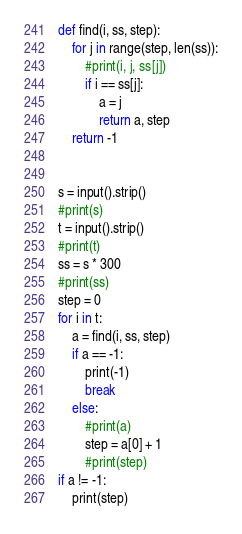Convert code to text. <code><loc_0><loc_0><loc_500><loc_500><_Python_>def find(i, ss, step):
    for j in range(step, len(ss)):
        #print(i, j, ss[j])
        if i == ss[j]:
            a = j
            return a, step
    return -1


s = input().strip()
#print(s)
t = input().strip()
#print(t)
ss = s * 300
#print(ss)
step = 0
for i in t:
    a = find(i, ss, step)
    if a == -1:
        print(-1)
        break
    else:
        #print(a)
        step = a[0] + 1
        #print(step)
if a != -1:
    print(step)
</code> 